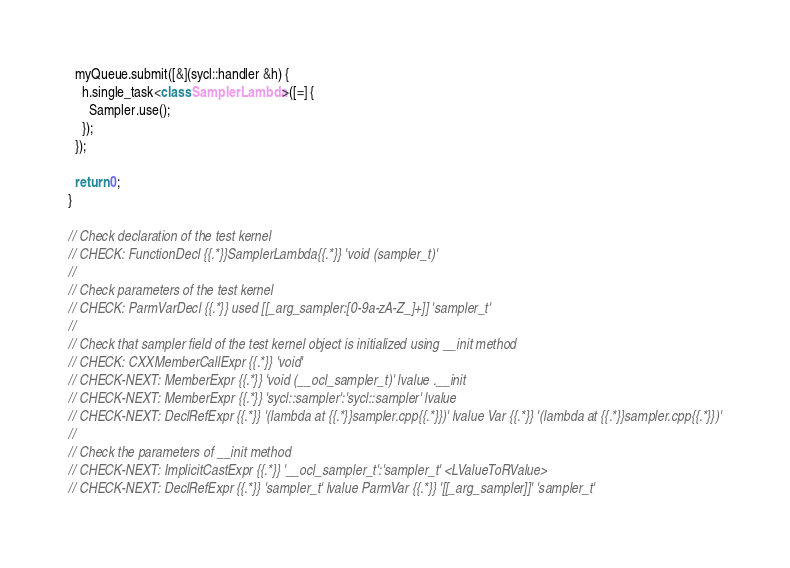Convert code to text. <code><loc_0><loc_0><loc_500><loc_500><_C++_>  myQueue.submit([&](sycl::handler &h) {
    h.single_task<class SamplerLambda>([=] {
      Sampler.use();
    });
  });

  return 0;
}

// Check declaration of the test kernel
// CHECK: FunctionDecl {{.*}}SamplerLambda{{.*}} 'void (sampler_t)'
//
// Check parameters of the test kernel
// CHECK: ParmVarDecl {{.*}} used [[_arg_sampler:[0-9a-zA-Z_]+]] 'sampler_t'
//
// Check that sampler field of the test kernel object is initialized using __init method
// CHECK: CXXMemberCallExpr {{.*}} 'void'
// CHECK-NEXT: MemberExpr {{.*}} 'void (__ocl_sampler_t)' lvalue .__init
// CHECK-NEXT: MemberExpr {{.*}} 'sycl::sampler':'sycl::sampler' lvalue
// CHECK-NEXT: DeclRefExpr {{.*}} '(lambda at {{.*}}sampler.cpp{{.*}})' lvalue Var {{.*}} '(lambda at {{.*}}sampler.cpp{{.*}})'
//
// Check the parameters of __init method
// CHECK-NEXT: ImplicitCastExpr {{.*}} '__ocl_sampler_t':'sampler_t' <LValueToRValue>
// CHECK-NEXT: DeclRefExpr {{.*}} 'sampler_t' lvalue ParmVar {{.*}} '[[_arg_sampler]]' 'sampler_t'
</code> 